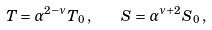<formula> <loc_0><loc_0><loc_500><loc_500>T = \alpha ^ { 2 - \nu } T _ { 0 } \, , \quad S = \alpha ^ { \nu + 2 } S _ { 0 } \, ,</formula> 